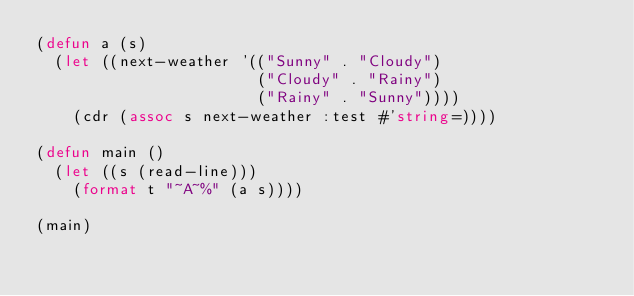<code> <loc_0><loc_0><loc_500><loc_500><_Lisp_>(defun a (s)
  (let ((next-weather '(("Sunny" . "Cloudy")                       
                        ("Cloudy" . "Rainy")
                        ("Rainy" . "Sunny"))))
    (cdr (assoc s next-weather :test #'string=))))

(defun main ()
  (let ((s (read-line)))
    (format t "~A~%" (a s))))

(main)
</code> 